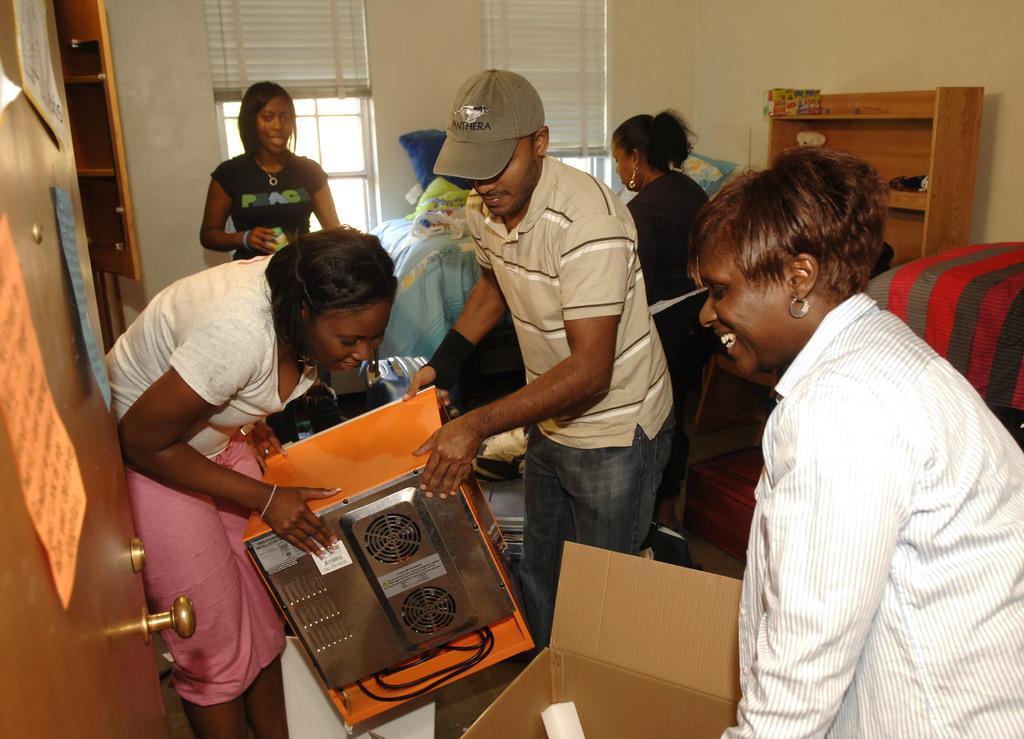In one or two sentences, can you explain what this image depicts? In this image I can see number of people are standing and in the centre I can see two of them are holding an orange colour thing. I can also see a box on the bottom side and on the left side of this image I can see few papers on a door. In the background I can see windows, window blinds and a wooden thing. I can also see few clothes in the background. 